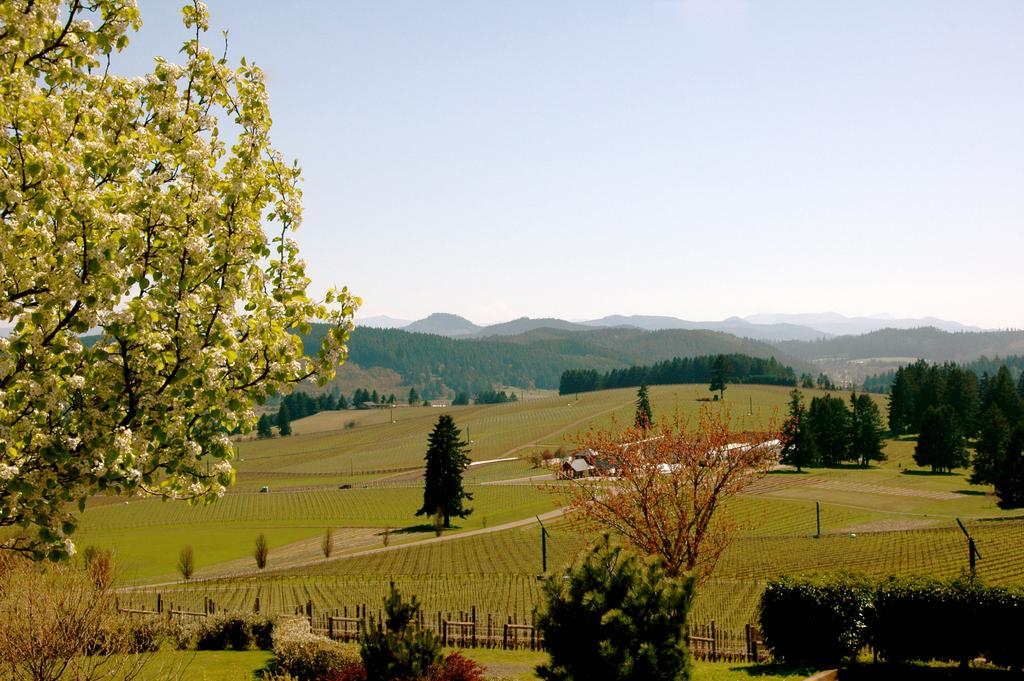What type of scenery is depicted in the image? The image contains a scenery that includes plants, grass, trees, crops, hills, and a railing. What can be seen in the sky in the image? The sky is visible in the image. What type of vegetation is present in the scenery? The scenery includes plants, grass, and trees. What type of landscape feature is included in the scenery? The scenery includes hills. What structure is present in the image? There is a railing in the image. What type of sign can be seen in the image? There is no sign present in the image; it features a scenery with plants, grass, trees, crops, hills, a railing, and a visible sky. 